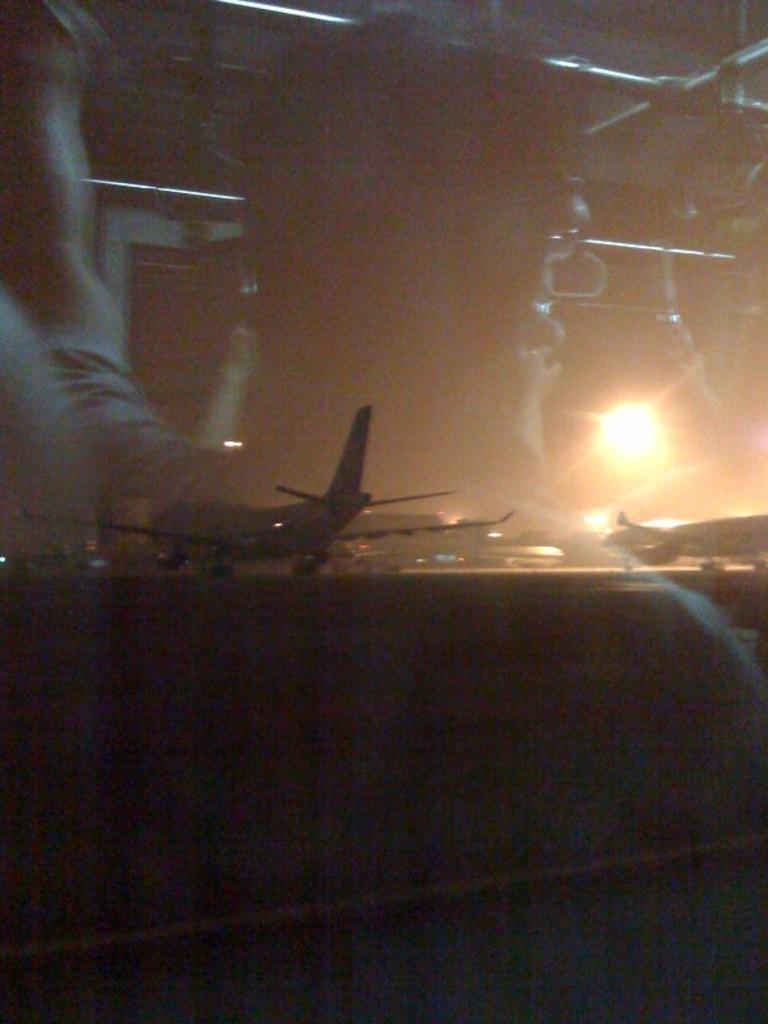How would you summarize this image in a sentence or two? In this picture we can see reflection of persons on the glass. From the glass we can see an aeroplane and this is light. 